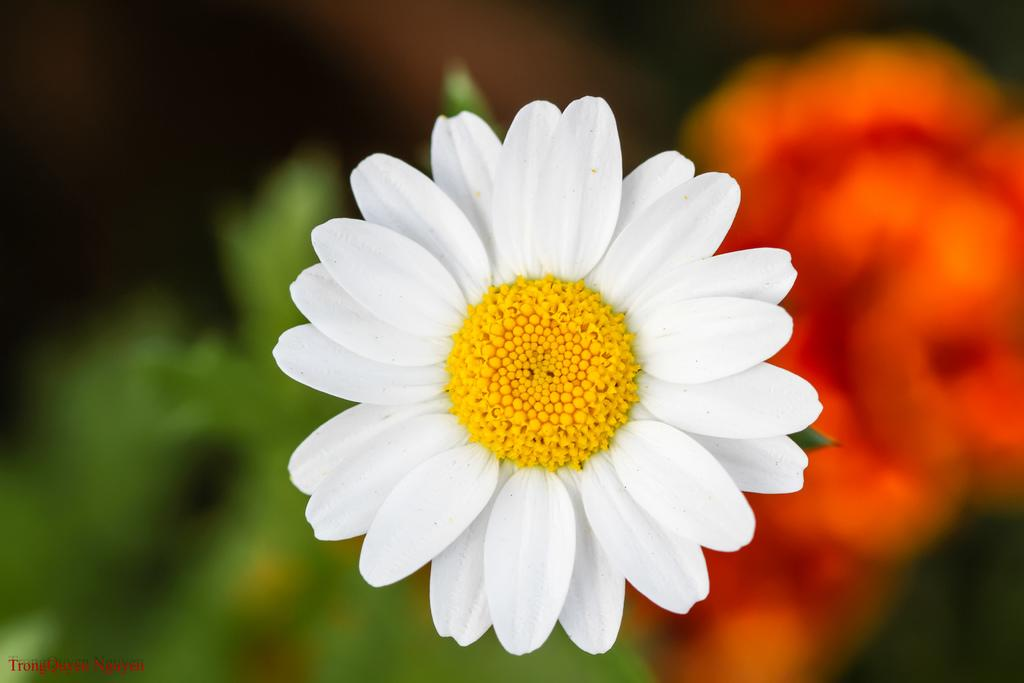What type of flower is in the image? There is a white-colored flower in the image. Can you describe the background of the image? The background of the image is blurred. What type of sponge is used for the art in the image? There is no sponge or art present in the image; it features a white-colored flower with a blurred background. 